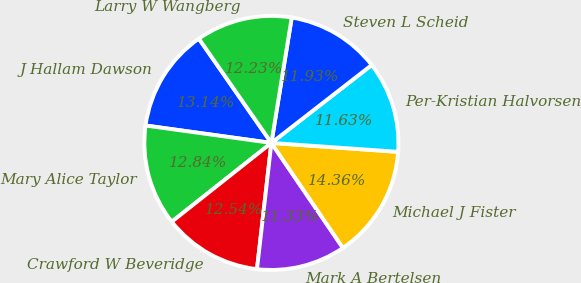Convert chart. <chart><loc_0><loc_0><loc_500><loc_500><pie_chart><fcel>J Hallam Dawson<fcel>Mary Alice Taylor<fcel>Crawford W Beveridge<fcel>Mark A Bertelsen<fcel>Michael J Fister<fcel>Per-Kristian Halvorsen<fcel>Steven L Scheid<fcel>Larry W Wangberg<nl><fcel>13.14%<fcel>12.84%<fcel>12.54%<fcel>11.33%<fcel>14.36%<fcel>11.63%<fcel>11.93%<fcel>12.23%<nl></chart> 